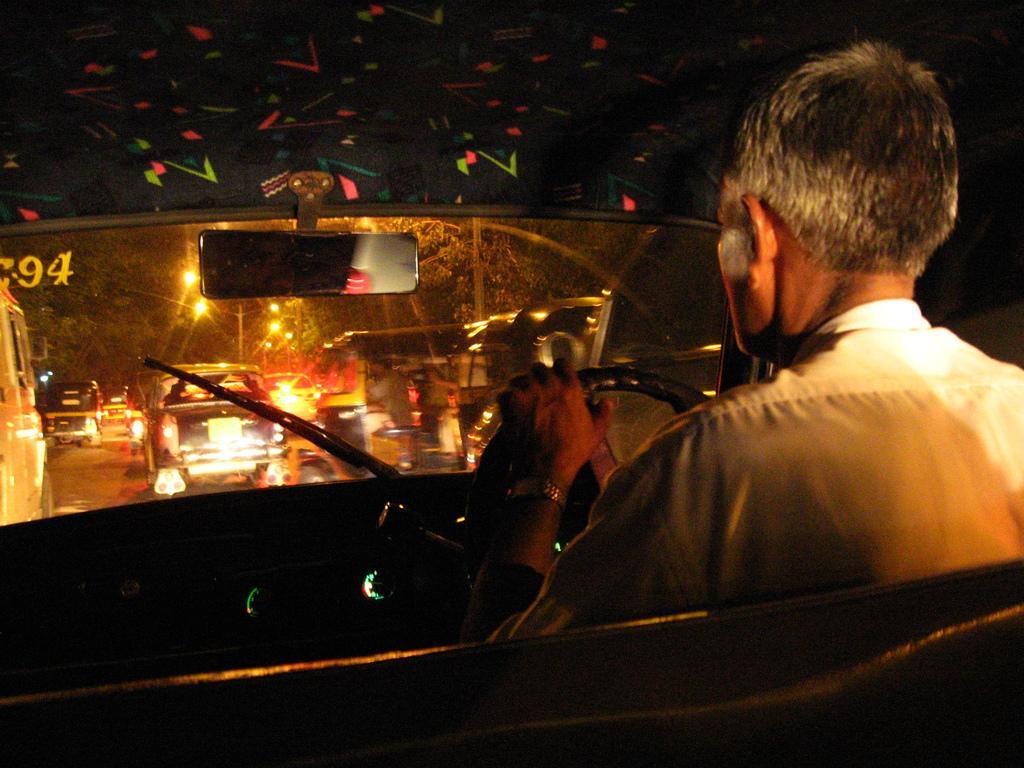How would you summarize this image in a sentence or two? In this image I can see the inside of a car and a man driving it. I can see that the man is wearing a wrist watch which is of golden in color, I can also see that there is a wiper on the windshield and a mirror attached to the vehicle. There are number of vehicles on the road and there are also number of trees. 